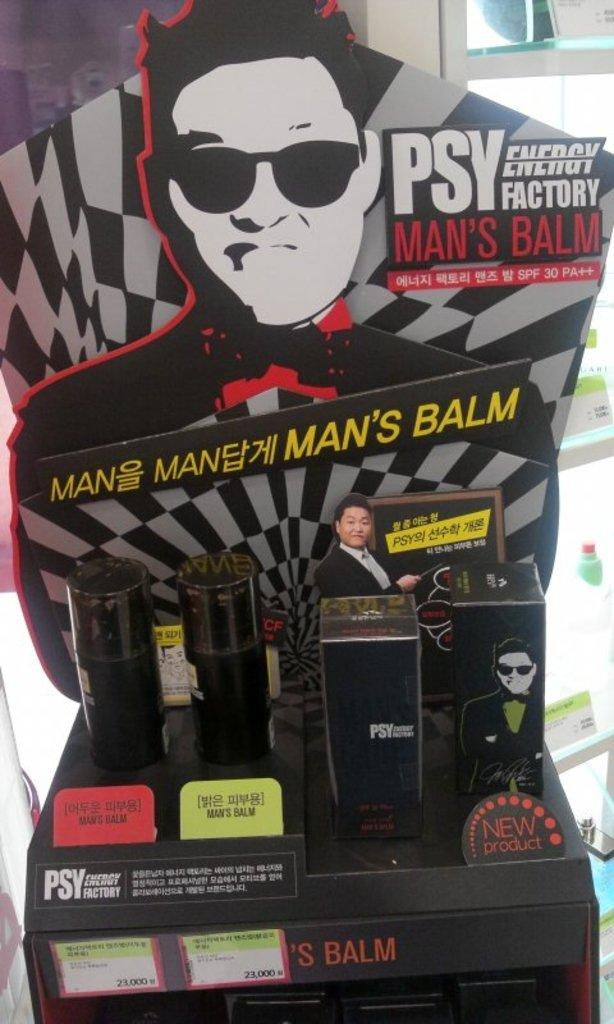<image>
Give a short and clear explanation of the subsequent image. A display with Psy Man's Balm products on it. 